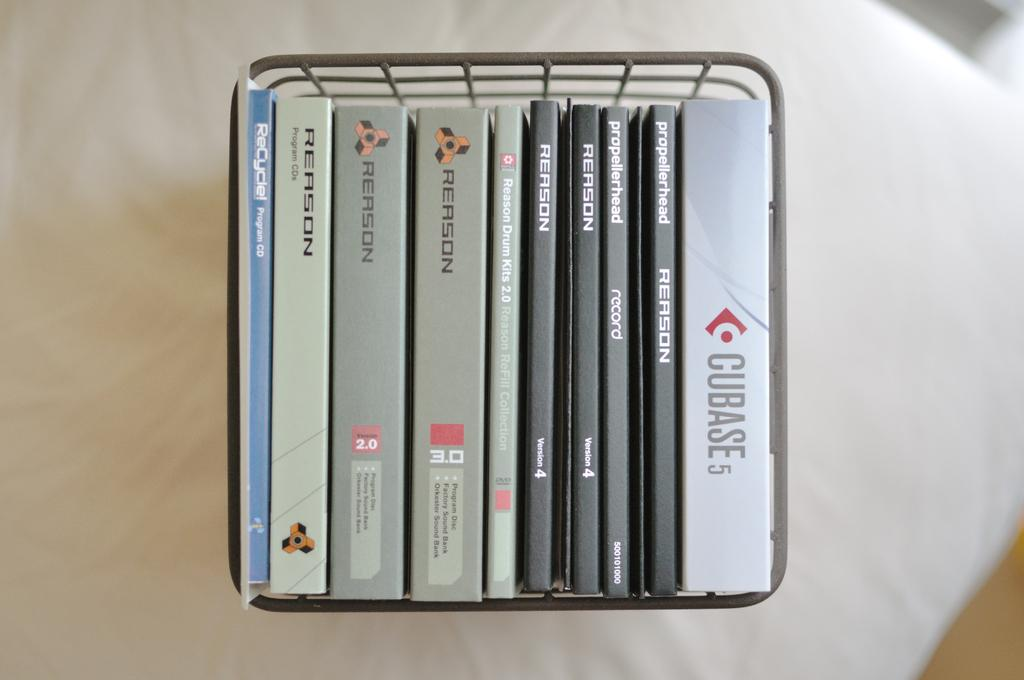<image>
Provide a brief description of the given image. A number of disc cases such as Cubase5 in a container. 